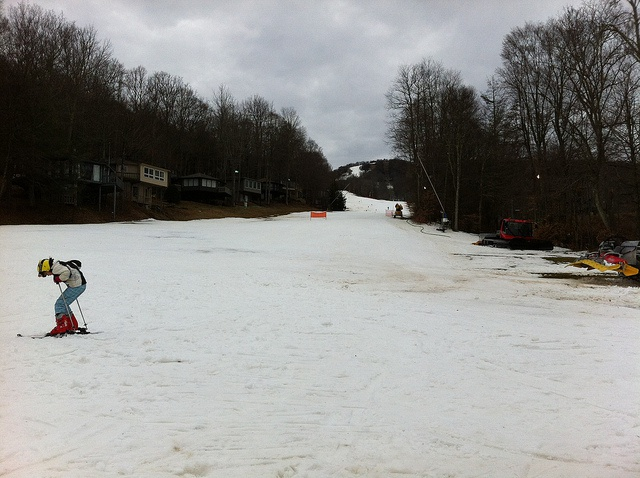Describe the objects in this image and their specific colors. I can see people in darkgray, gray, black, and maroon tones, skis in darkgray, lightgray, and gray tones, and backpack in darkgray, black, gray, and lightgray tones in this image. 